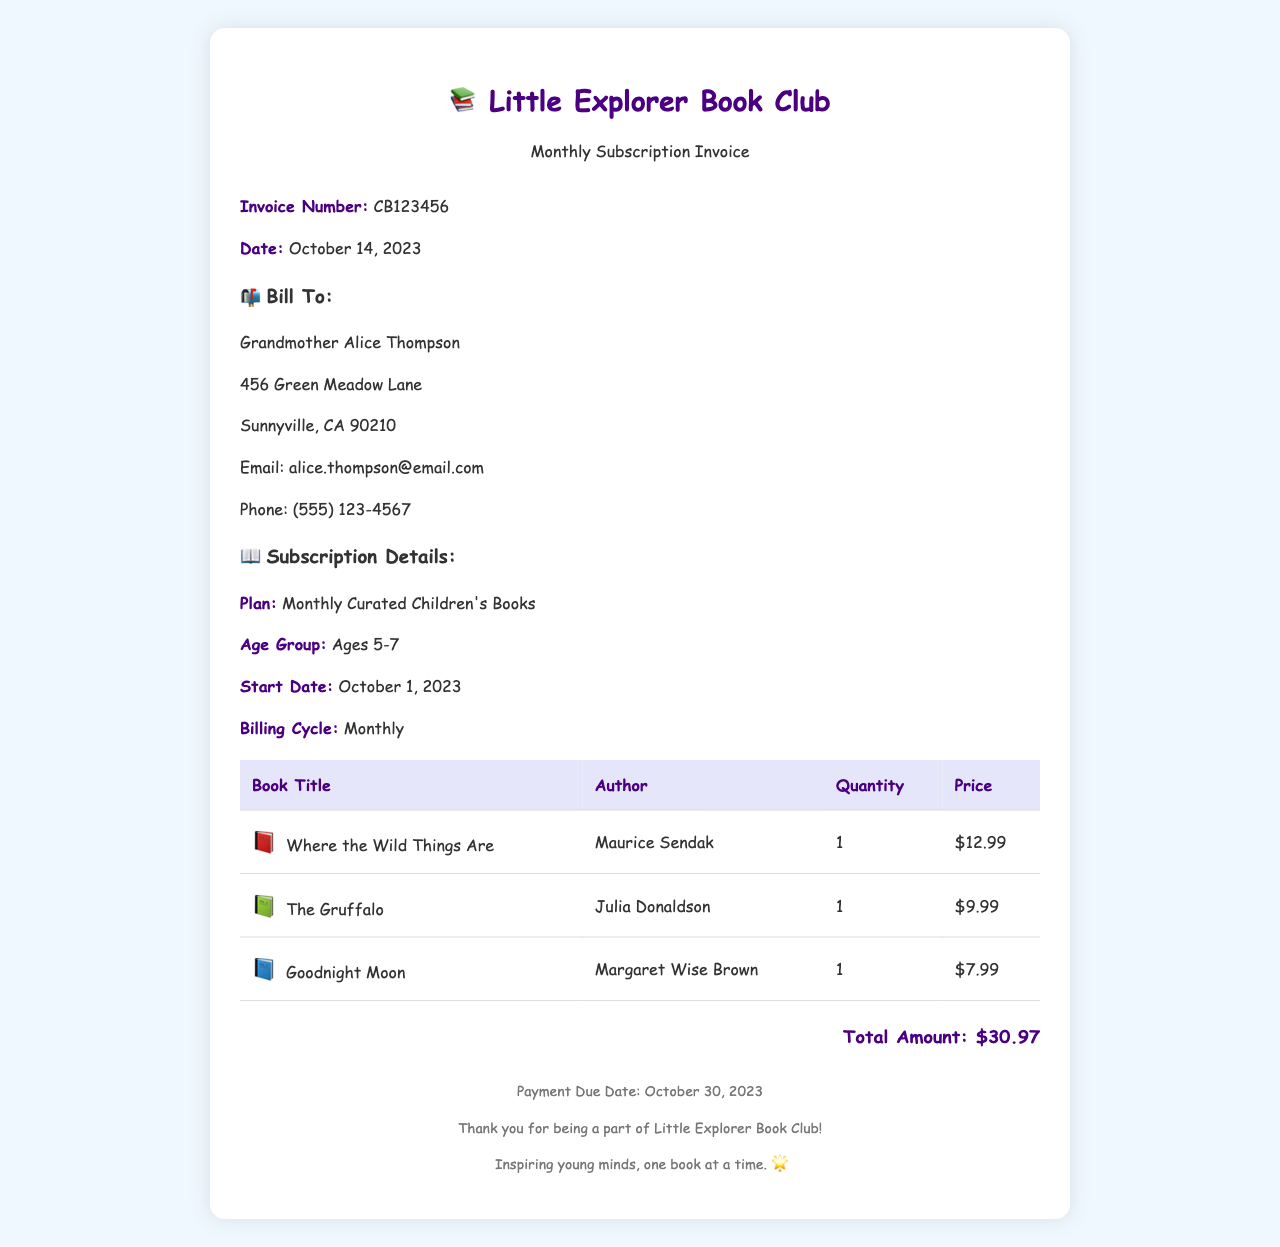What is the invoice number? The invoice number is mentioned in the invoice details section, which is CB123456.
Answer: CB123456 Who is the bill to? The customer details section specifies the person to whom the invoice is billed, which is Grandmother Alice Thompson.
Answer: Grandmother Alice Thompson What is the total amount due? The total amount is provided at the end of the invoice, which is the sum of the prices of the books listed.
Answer: $30.97 What age group are the books curated for? The subscription details mention the age group for which the books are curated, which is Ages 5-7.
Answer: Ages 5-7 What is the payment due date? The due date for payment is stated in the footer of the invoice, which is October 30, 2023.
Answer: October 30, 2023 How many books are listed in the invoice? The table contains three rows for different book titles, indicating the number of books included in the invoice.
Answer: 3 What is the start date of the subscription? The subscription details section lists the start date, which is October 1, 2023.
Answer: October 1, 2023 Which book has the highest price? By comparing the prices in the table, it is clear that Where the Wild Things Are is the most expensive book at $12.99.
Answer: Where the Wild Things Are 